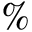<formula> <loc_0><loc_0><loc_500><loc_500>\%</formula> 